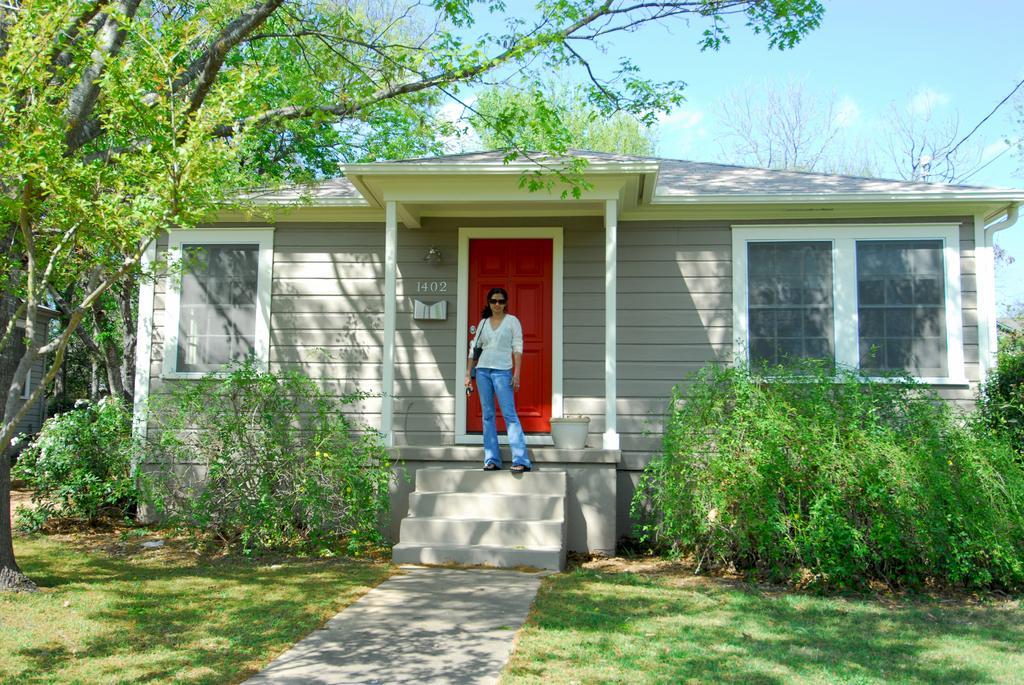How would you summarize this image in a sentence or two? In this image I can see a white color house and i can see a woman standing on staircase , in front of a red color door , under the house , at the top I can see sky and in front of the house I can see plants on the left side I can see tree. 